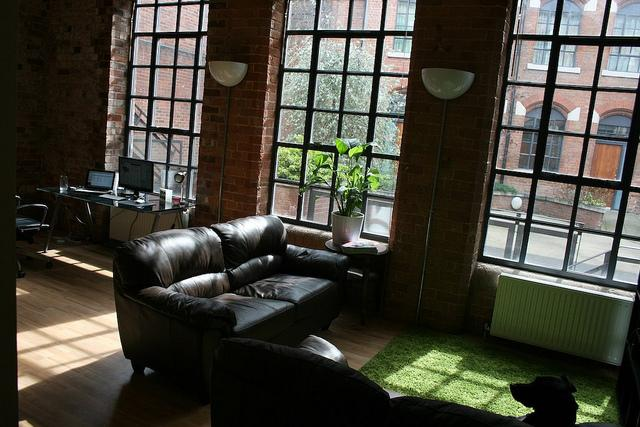Which two species often share this space?

Choices:
A) humans dogs
B) none
C) snakes alligators
D) hobbit ents humans dogs 